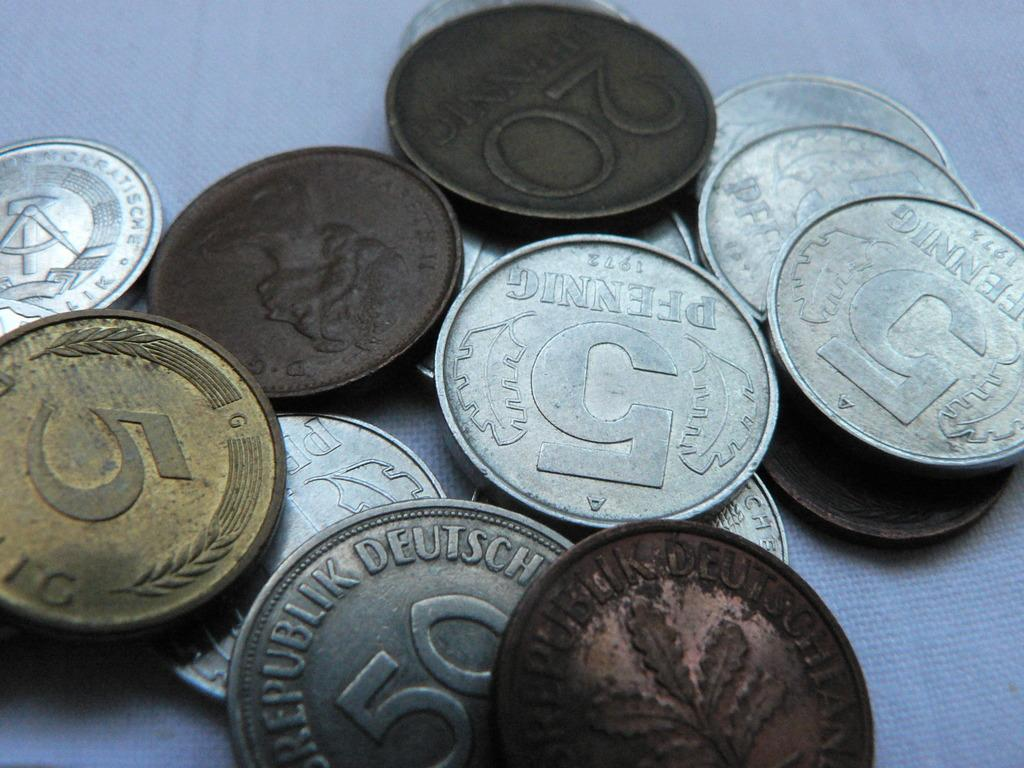<image>
Provide a brief description of the given image. several old Deustchland coins like 5 and 20 Pfennig 